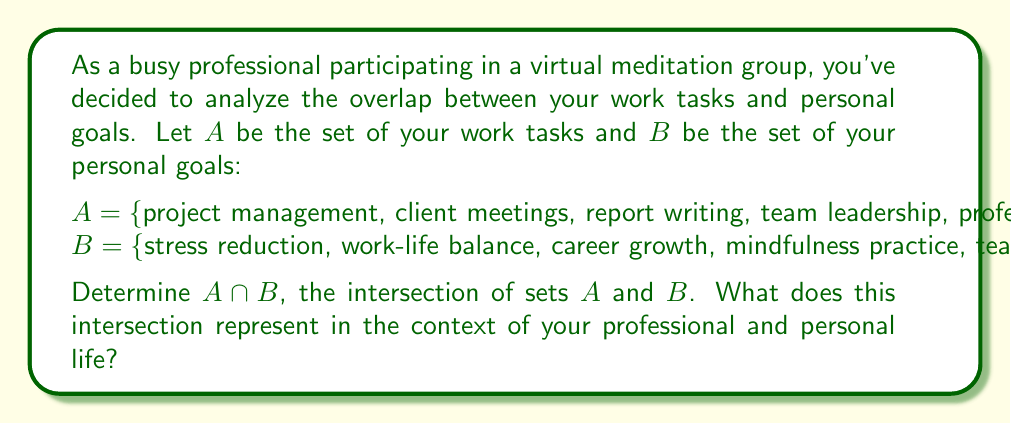Show me your answer to this math problem. To find the intersection of sets $A$ and $B$, we need to identify the elements that are common to both sets. Let's analyze each element:

1. project management: only in $A$
2. client meetings: only in $A$
3. report writing: only in $A$
4. team leadership: in both $A$ and $B$
5. professional development: only in $A$
6. stress reduction: only in $B$
7. work-life balance: only in $B$
8. career growth: only in $B$
9. mindfulness practice: only in $B$

The only element that appears in both sets is "team leadership". Therefore,

$$A \cap B = \{\text{team leadership}\}$$

In the context of your professional and personal life, this intersection represents an area where your work responsibilities align with your personal goals. Team leadership is both a work task and a personal development goal, indicating that you can potentially achieve personal growth while fulfilling your professional duties.

This alignment can be beneficial as it allows you to focus on an area that contributes to both your career and personal aspirations simultaneously. It may also indicate an opportunity to apply mindfulness and stress reduction techniques (from your meditation practice) to your team leadership role, potentially improving your effectiveness as a leader and contributing to your work-life balance.
Answer: $A \cap B = \{\text{team leadership}\}$ 